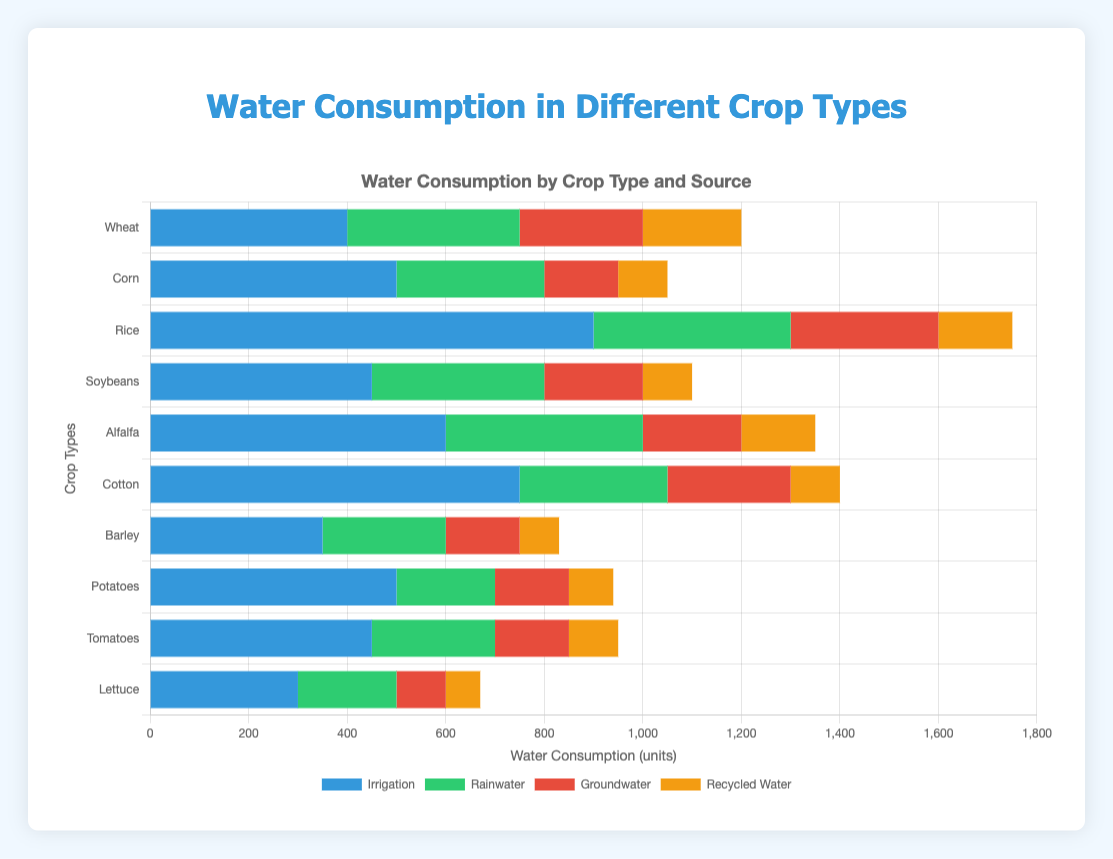What crop consumes the most water from irrigation sources? Look at the irrigation section of each crop and compare their values. Rice has the highest value of 900.
Answer: Rice Which crop has the least consumption of groundwater sources? Check the groundwater section for each crop and identify the lowest value. Corn and Barley both consume 150 units from groundwater.
Answer: Corn and Barley Which water source is most frequently highest across different crop types? For each crop, identify which water source is the highest. Irrigation is the most frequently highest source for 8 out of 10 crops (Wheat, Corn, Rice, Soybeans, Alfalfa, Cotton, Potatoes, Tomatoes).
Answer: Irrigation How much more irrigation water does Cotton consume compared to Lettuce? Subtract the irrigation water consumed by Lettuce (300) from that consumed by Cotton (750). 750 - 300 = 450.
Answer: 450 units What is the total water consumption for Soybeans? Sum up all four water sources consumed by Soybeans. 450 (Irrigation) + 350 (Rainwater) + 200 (Groundwater) + 100 (Recycled Water) = 1100.
Answer: 1100 units Which crop has the highest percentage of its total water consumption coming from rainwater? Calculate the total water consumption for each crop and find the percentage that comes from rainwater. Focus particularly on the numerator (rainwater) and the sum of the four sources as the denominator. For example, for Soybeans: (350/1100) = 31.82%. Perform similar calculations for each crop and compare.
Answer: Rice or Alfalfa (both around 29%) Compare the total recycled water consumption between Rice and Corn. Which one is higher? Add up the recycled water for Rice (150 units) and Corn (100 units) and compare. 150 > 100.
Answer: Rice What is the combined water consumption from groundwater and recycled water for Wheat? Add the groundwater consumption (250) and recycled water consumption (200) for Wheat. 250 + 200 = 450.
Answer: 450 units Which crop shows the smallest use of recycled water? Look at the recycled water section for each crop and find the smallest value. Barley uses 80 units, which is the smallest.
Answer: Barley How does the total water consumption for Cotton compare to Corn? Calculate the total water consumption for Cotton (750 + 300 + 250 + 100 = 1400) and Corn (500 + 300 + 150 + 100 = 1050) and compare the totals. 1400 > 1050.
Answer: Cotton 